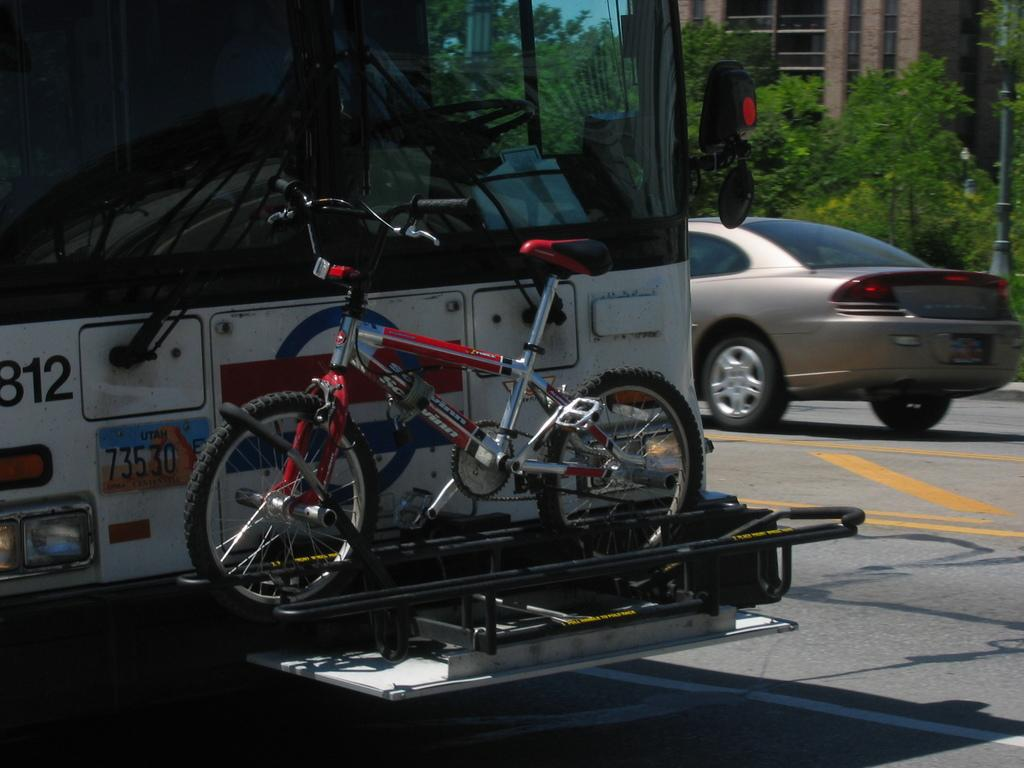What type of vehicle is the largest in the image? The truck is the largest vehicle in the image. What other type of vehicle is present in the image? There is a bicycle and a car in the image. What can be seen in the background of the image? There are trees and a building in the image. What is the chance of the scale tipping over in the image? There is no scale present in the image, so it cannot tip over. 